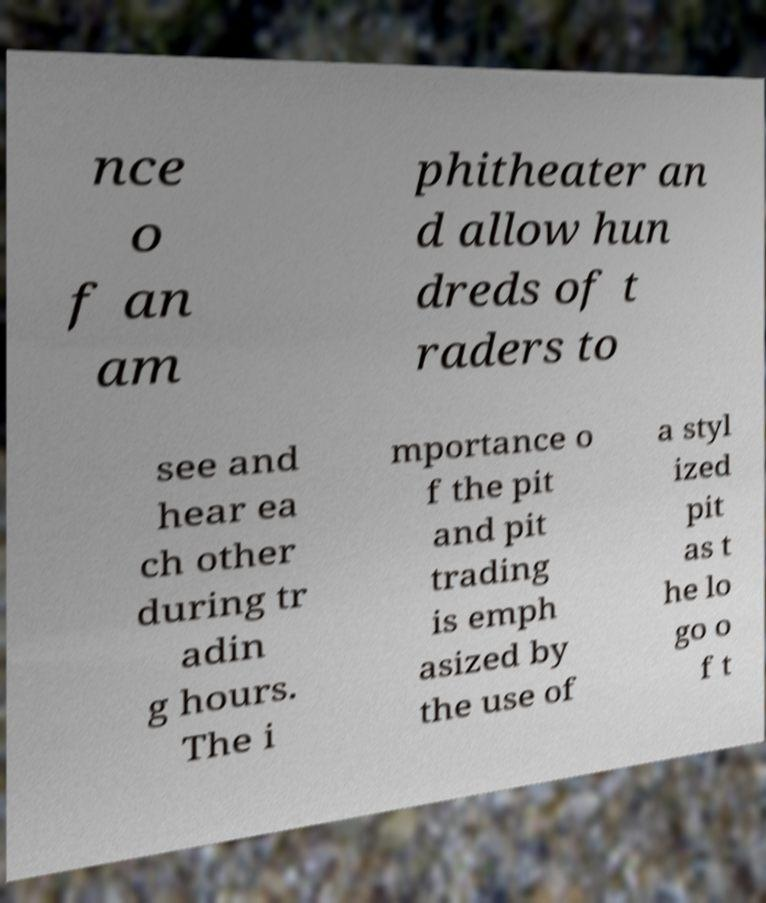Could you extract and type out the text from this image? nce o f an am phitheater an d allow hun dreds of t raders to see and hear ea ch other during tr adin g hours. The i mportance o f the pit and pit trading is emph asized by the use of a styl ized pit as t he lo go o f t 